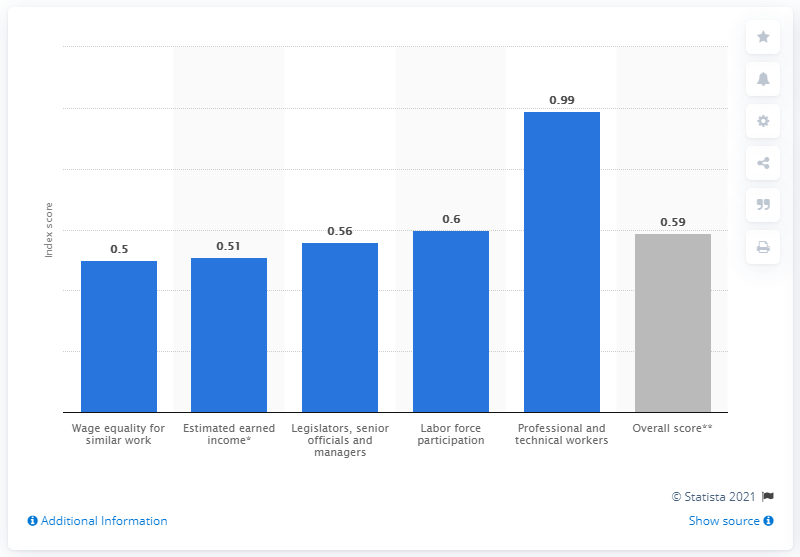Outline some significant characteristics in this image. In 2021, the gender gap index score for Mexico was 0.59, indicating a moderate gender disparity in various aspects such as education, health, economic participation and political representation. 